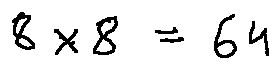<formula> <loc_0><loc_0><loc_500><loc_500>8 \times 8 = 6 4</formula> 